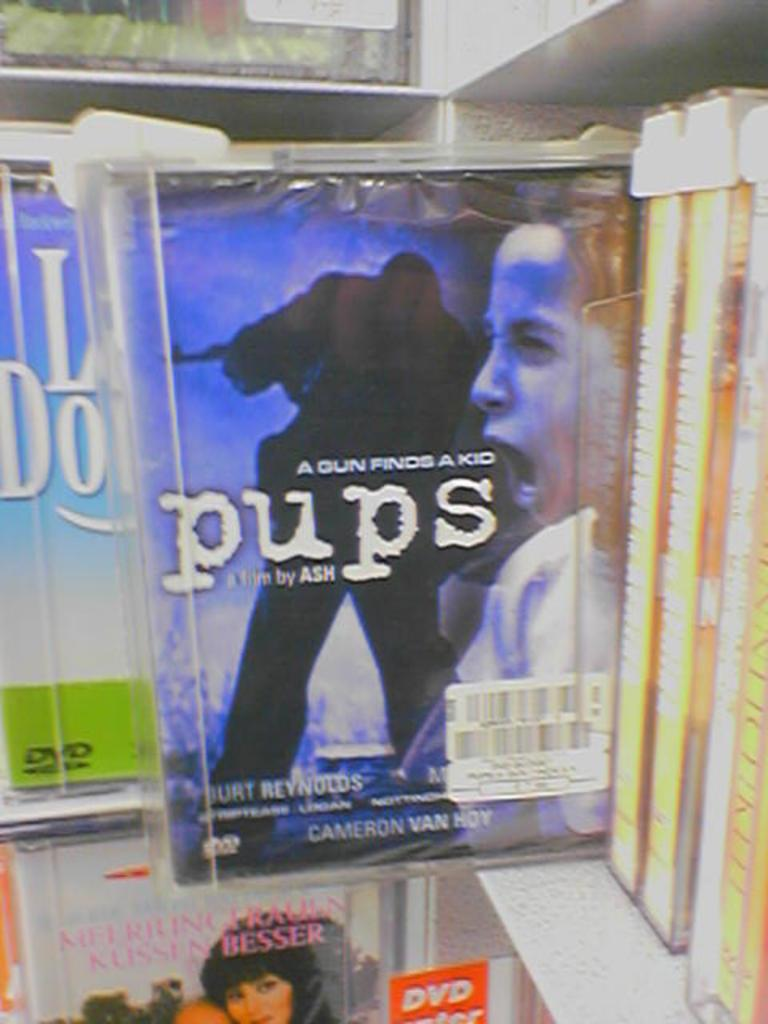<image>
Summarize the visual content of the image. Cover for a movie titled the pups showing a man screaming. 